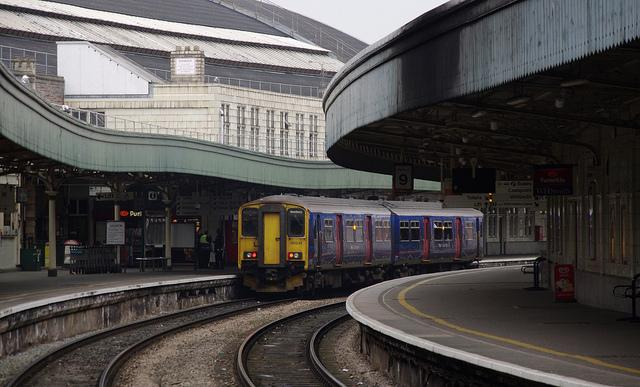Why is the yellow line painted on the ground?

Choices:
A) decoration
B) safety
C) vandalism
D) amusement safety 